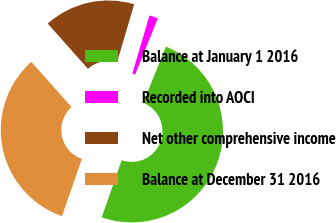Convert chart. <chart><loc_0><loc_0><loc_500><loc_500><pie_chart><fcel>Balance at January 1 2016<fcel>Recorded into AOCI<fcel>Net other comprehensive income<fcel>Balance at December 31 2016<nl><fcel>49.23%<fcel>1.54%<fcel>16.15%<fcel>33.08%<nl></chart> 